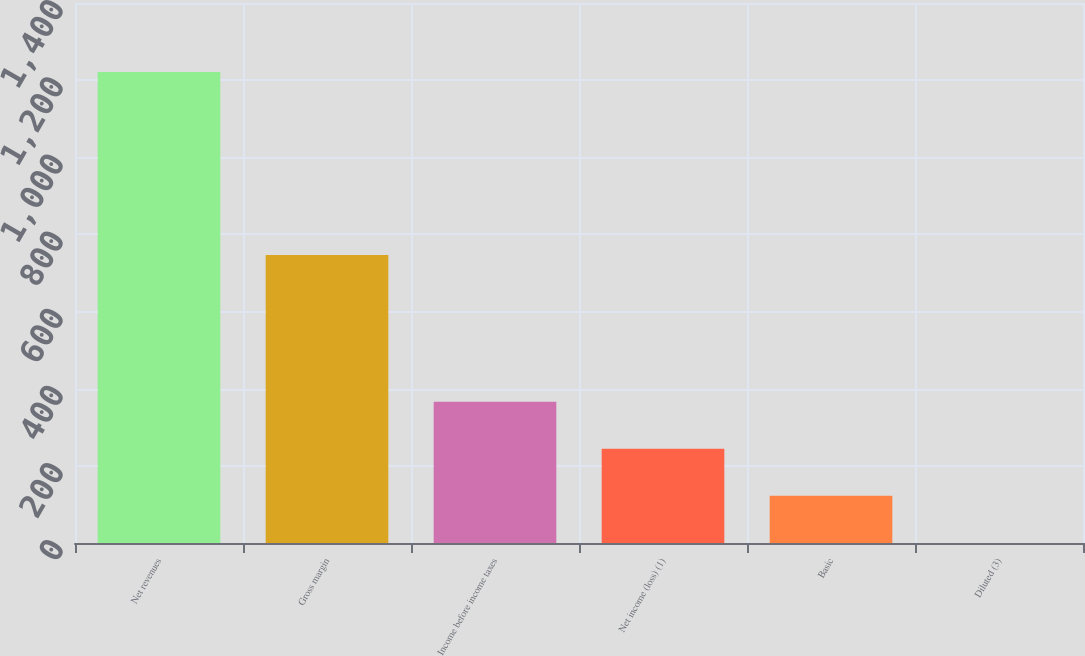Convert chart to OTSL. <chart><loc_0><loc_0><loc_500><loc_500><bar_chart><fcel>Net revenues<fcel>Gross margin<fcel>Income before income taxes<fcel>Net income (loss) (1)<fcel>Basic<fcel>Diluted (3)<nl><fcel>1221<fcel>746.6<fcel>366.49<fcel>244.42<fcel>122.35<fcel>0.28<nl></chart> 